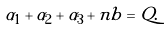Convert formula to latex. <formula><loc_0><loc_0><loc_500><loc_500>\alpha _ { 1 } + \alpha _ { 2 } + \alpha _ { 3 } + n b = Q .</formula> 